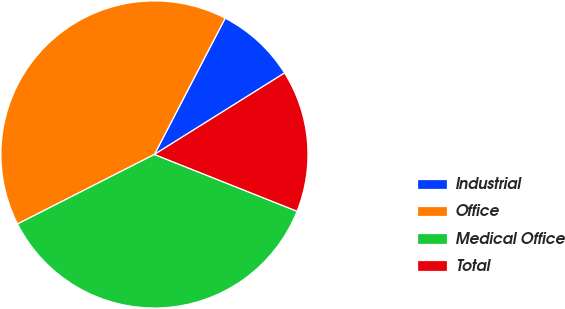Convert chart to OTSL. <chart><loc_0><loc_0><loc_500><loc_500><pie_chart><fcel>Industrial<fcel>Office<fcel>Medical Office<fcel>Total<nl><fcel>8.48%<fcel>40.1%<fcel>36.49%<fcel>14.93%<nl></chart> 